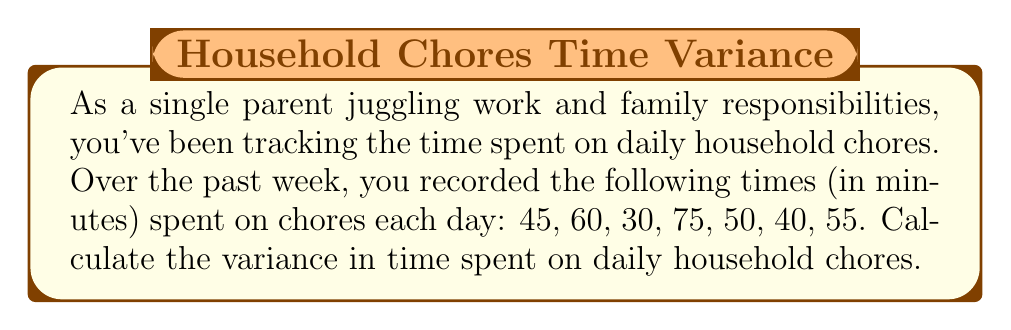Provide a solution to this math problem. To find the variance, we'll follow these steps:

1. Calculate the mean (average) time:
   $$\mu = \frac{45 + 60 + 30 + 75 + 50 + 40 + 55}{7} = 50.71$$

2. Calculate the squared differences from the mean:
   $$(45 - 50.71)^2 = (-5.71)^2 = 32.60$$
   $$(60 - 50.71)^2 = (9.29)^2 = 86.30$$
   $$(30 - 50.71)^2 = (-20.71)^2 = 428.90$$
   $$(75 - 50.71)^2 = (24.29)^2 = 590.00$$
   $$(50 - 50.71)^2 = (-0.71)^2 = 0.50$$
   $$(40 - 50.71)^2 = (-10.71)^2 = 114.70$$
   $$(55 - 50.71)^2 = (4.29)^2 = 18.40$$

3. Sum the squared differences:
   $$32.60 + 86.30 + 428.90 + 590.00 + 0.50 + 114.70 + 18.40 = 1271.40$$

4. Divide by the number of days (n = 7) to get the variance:
   $$\text{Variance} = \frac{1271.40}{7} = 181.63$$

Therefore, the variance in time spent on daily household chores is approximately 181.63 square minutes.
Answer: 181.63 square minutes 